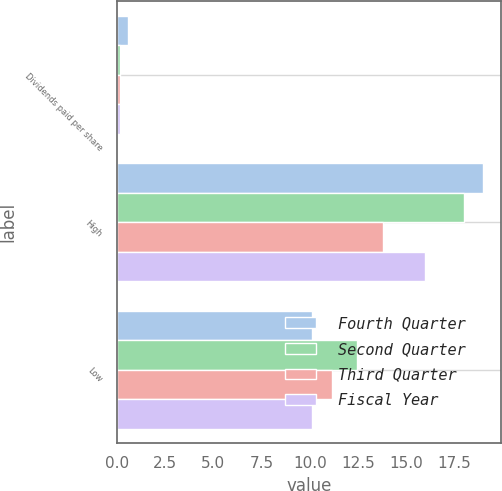Convert chart to OTSL. <chart><loc_0><loc_0><loc_500><loc_500><stacked_bar_chart><ecel><fcel>Dividends paid per share<fcel>High<fcel>Low<nl><fcel>Fourth Quarter<fcel>0.6<fcel>18.99<fcel>10.13<nl><fcel>Second Quarter<fcel>0.15<fcel>18<fcel>12.46<nl><fcel>Third Quarter<fcel>0.15<fcel>13.79<fcel>11.15<nl><fcel>Fiscal Year<fcel>0.15<fcel>15.97<fcel>10.13<nl></chart> 